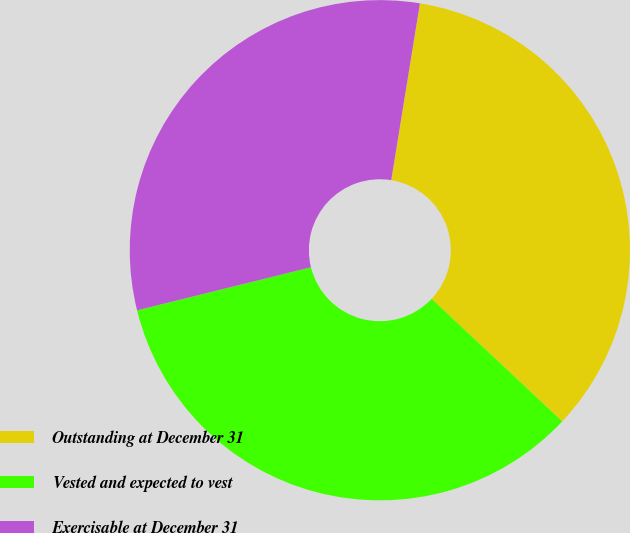<chart> <loc_0><loc_0><loc_500><loc_500><pie_chart><fcel>Outstanding at December 31<fcel>Vested and expected to vest<fcel>Exercisable at December 31<nl><fcel>34.44%<fcel>34.14%<fcel>31.42%<nl></chart> 